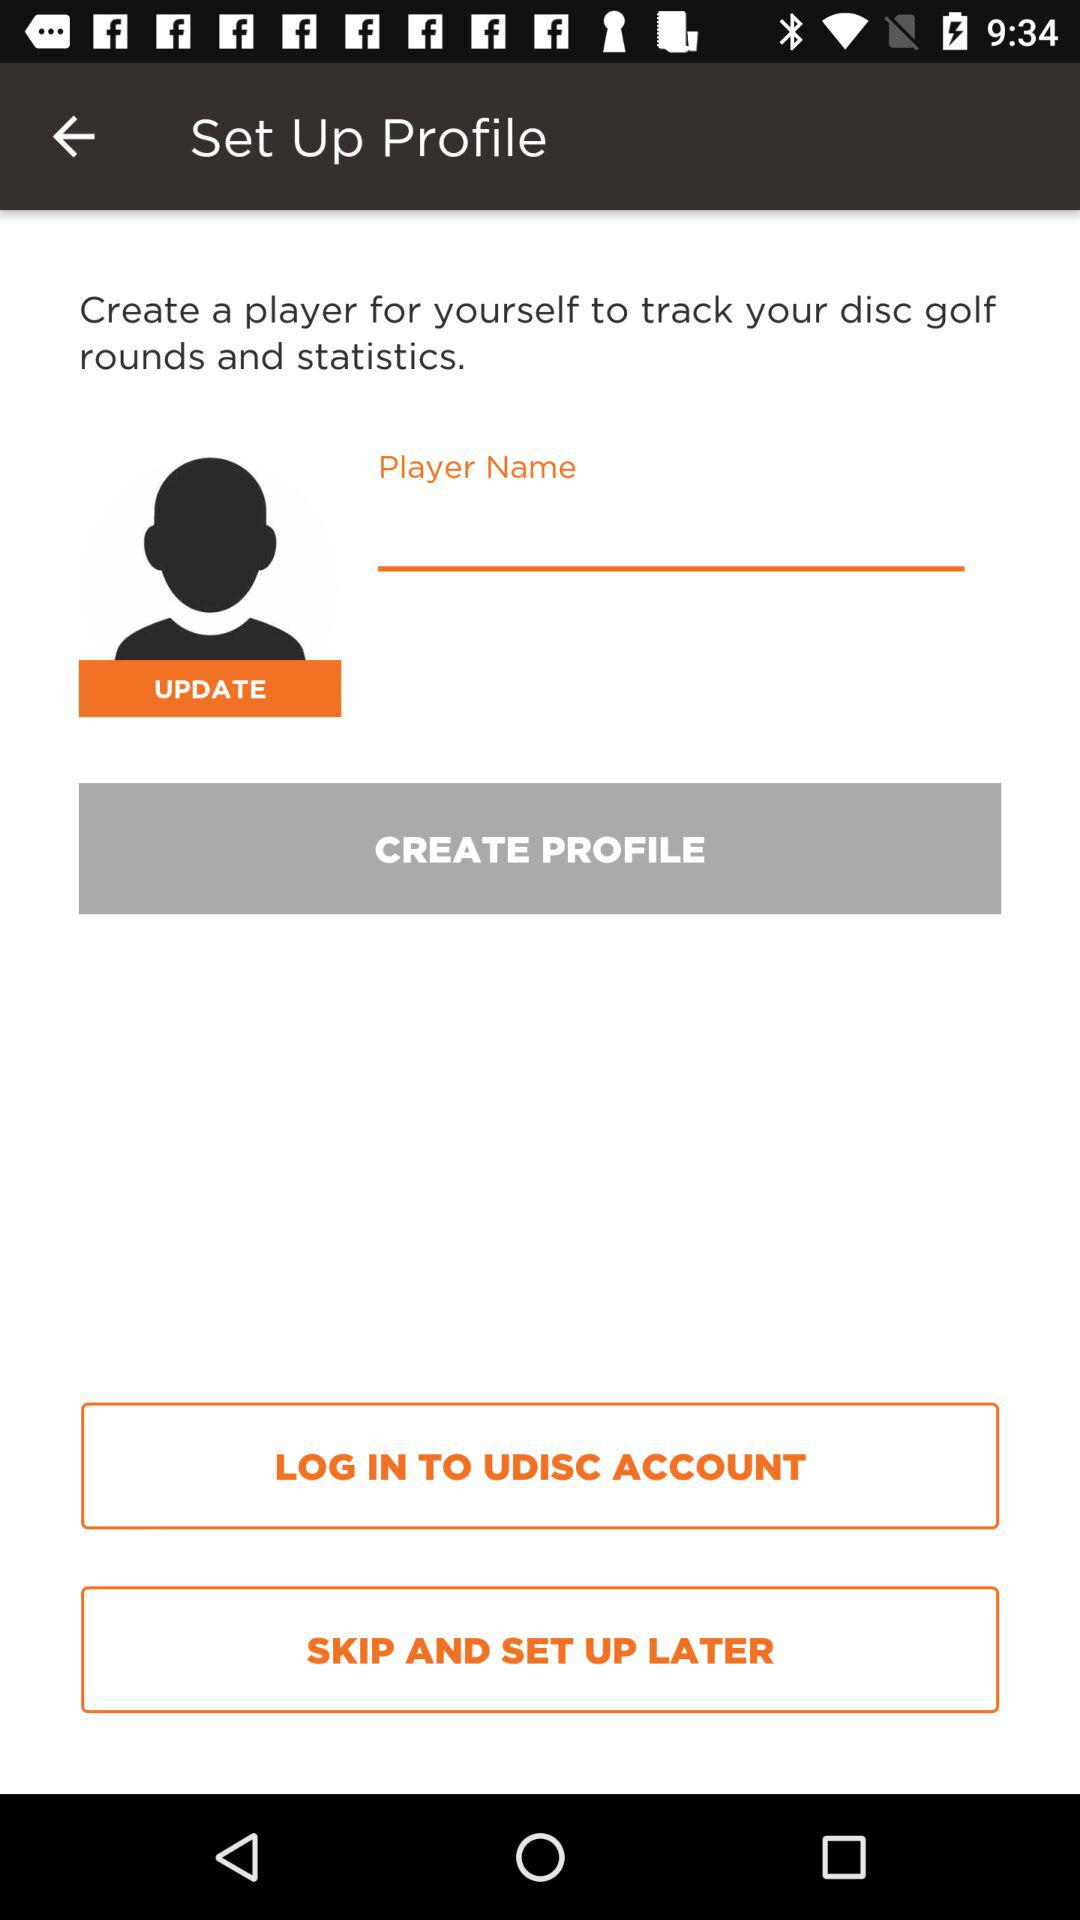What account can I log in? You can log in with "UDISC". 